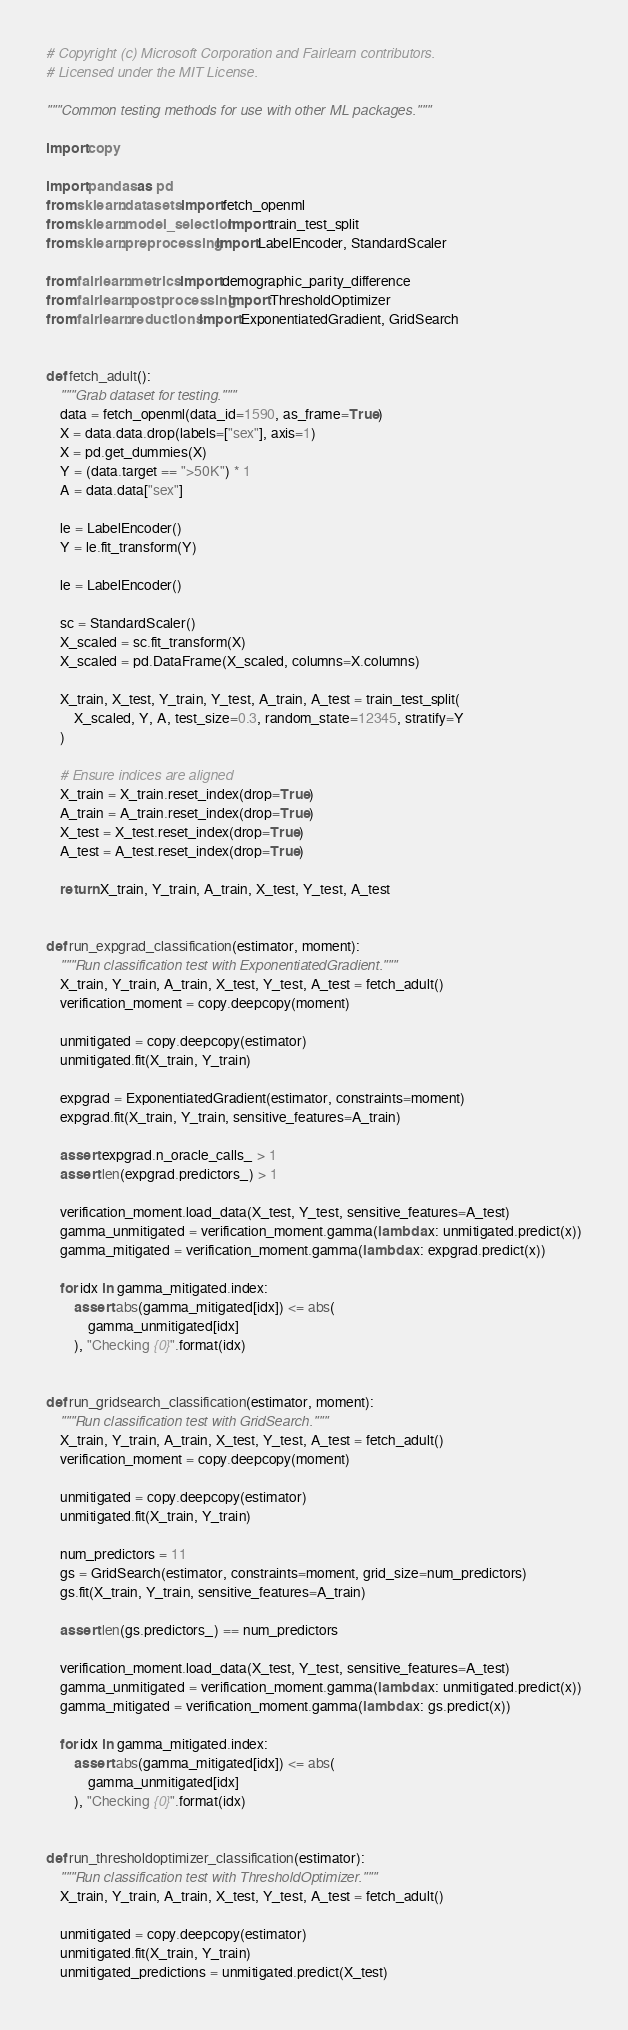Convert code to text. <code><loc_0><loc_0><loc_500><loc_500><_Python_># Copyright (c) Microsoft Corporation and Fairlearn contributors.
# Licensed under the MIT License.

"""Common testing methods for use with other ML packages."""

import copy

import pandas as pd
from sklearn.datasets import fetch_openml
from sklearn.model_selection import train_test_split
from sklearn.preprocessing import LabelEncoder, StandardScaler

from fairlearn.metrics import demographic_parity_difference
from fairlearn.postprocessing import ThresholdOptimizer
from fairlearn.reductions import ExponentiatedGradient, GridSearch


def fetch_adult():
    """Grab dataset for testing."""
    data = fetch_openml(data_id=1590, as_frame=True)
    X = data.data.drop(labels=["sex"], axis=1)
    X = pd.get_dummies(X)
    Y = (data.target == ">50K") * 1
    A = data.data["sex"]

    le = LabelEncoder()
    Y = le.fit_transform(Y)

    le = LabelEncoder()

    sc = StandardScaler()
    X_scaled = sc.fit_transform(X)
    X_scaled = pd.DataFrame(X_scaled, columns=X.columns)

    X_train, X_test, Y_train, Y_test, A_train, A_test = train_test_split(
        X_scaled, Y, A, test_size=0.3, random_state=12345, stratify=Y
    )

    # Ensure indices are aligned
    X_train = X_train.reset_index(drop=True)
    A_train = A_train.reset_index(drop=True)
    X_test = X_test.reset_index(drop=True)
    A_test = A_test.reset_index(drop=True)

    return X_train, Y_train, A_train, X_test, Y_test, A_test


def run_expgrad_classification(estimator, moment):
    """Run classification test with ExponentiatedGradient."""
    X_train, Y_train, A_train, X_test, Y_test, A_test = fetch_adult()
    verification_moment = copy.deepcopy(moment)

    unmitigated = copy.deepcopy(estimator)
    unmitigated.fit(X_train, Y_train)

    expgrad = ExponentiatedGradient(estimator, constraints=moment)
    expgrad.fit(X_train, Y_train, sensitive_features=A_train)

    assert expgrad.n_oracle_calls_ > 1
    assert len(expgrad.predictors_) > 1

    verification_moment.load_data(X_test, Y_test, sensitive_features=A_test)
    gamma_unmitigated = verification_moment.gamma(lambda x: unmitigated.predict(x))
    gamma_mitigated = verification_moment.gamma(lambda x: expgrad.predict(x))

    for idx in gamma_mitigated.index:
        assert abs(gamma_mitigated[idx]) <= abs(
            gamma_unmitigated[idx]
        ), "Checking {0}".format(idx)


def run_gridsearch_classification(estimator, moment):
    """Run classification test with GridSearch."""
    X_train, Y_train, A_train, X_test, Y_test, A_test = fetch_adult()
    verification_moment = copy.deepcopy(moment)

    unmitigated = copy.deepcopy(estimator)
    unmitigated.fit(X_train, Y_train)

    num_predictors = 11
    gs = GridSearch(estimator, constraints=moment, grid_size=num_predictors)
    gs.fit(X_train, Y_train, sensitive_features=A_train)

    assert len(gs.predictors_) == num_predictors

    verification_moment.load_data(X_test, Y_test, sensitive_features=A_test)
    gamma_unmitigated = verification_moment.gamma(lambda x: unmitigated.predict(x))
    gamma_mitigated = verification_moment.gamma(lambda x: gs.predict(x))

    for idx in gamma_mitigated.index:
        assert abs(gamma_mitigated[idx]) <= abs(
            gamma_unmitigated[idx]
        ), "Checking {0}".format(idx)


def run_thresholdoptimizer_classification(estimator):
    """Run classification test with ThresholdOptimizer."""
    X_train, Y_train, A_train, X_test, Y_test, A_test = fetch_adult()

    unmitigated = copy.deepcopy(estimator)
    unmitigated.fit(X_train, Y_train)
    unmitigated_predictions = unmitigated.predict(X_test)
</code> 